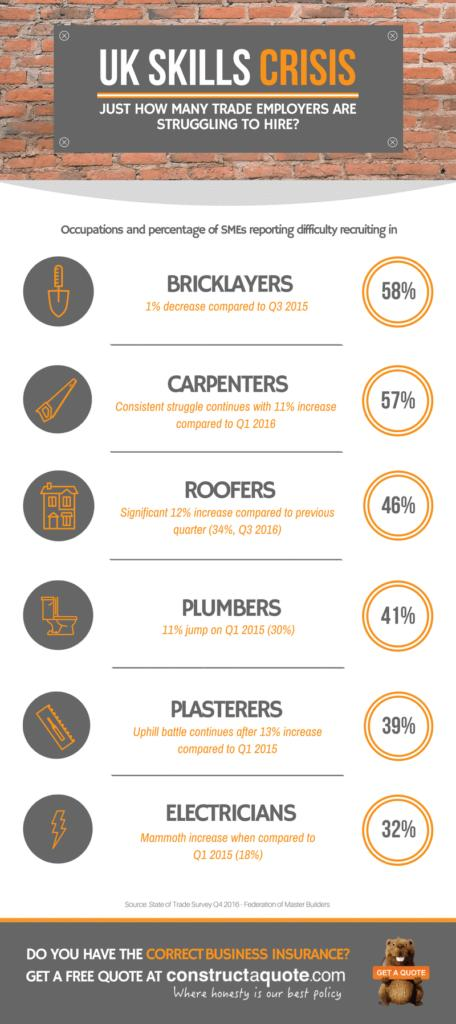Highlight a few significant elements in this photo. The percentage of bricklayers in the third quarter of 2015 was 59%. In the fourth quarter of 2016, the percentage of roofers was 46%. In Q1 2016, the percentage of carpenters was 46%. In Q1 2015, the percentage of plasterers was 26%. The increase in the percentage of electricians when compared to the first quarter of 2015 is 14%. 